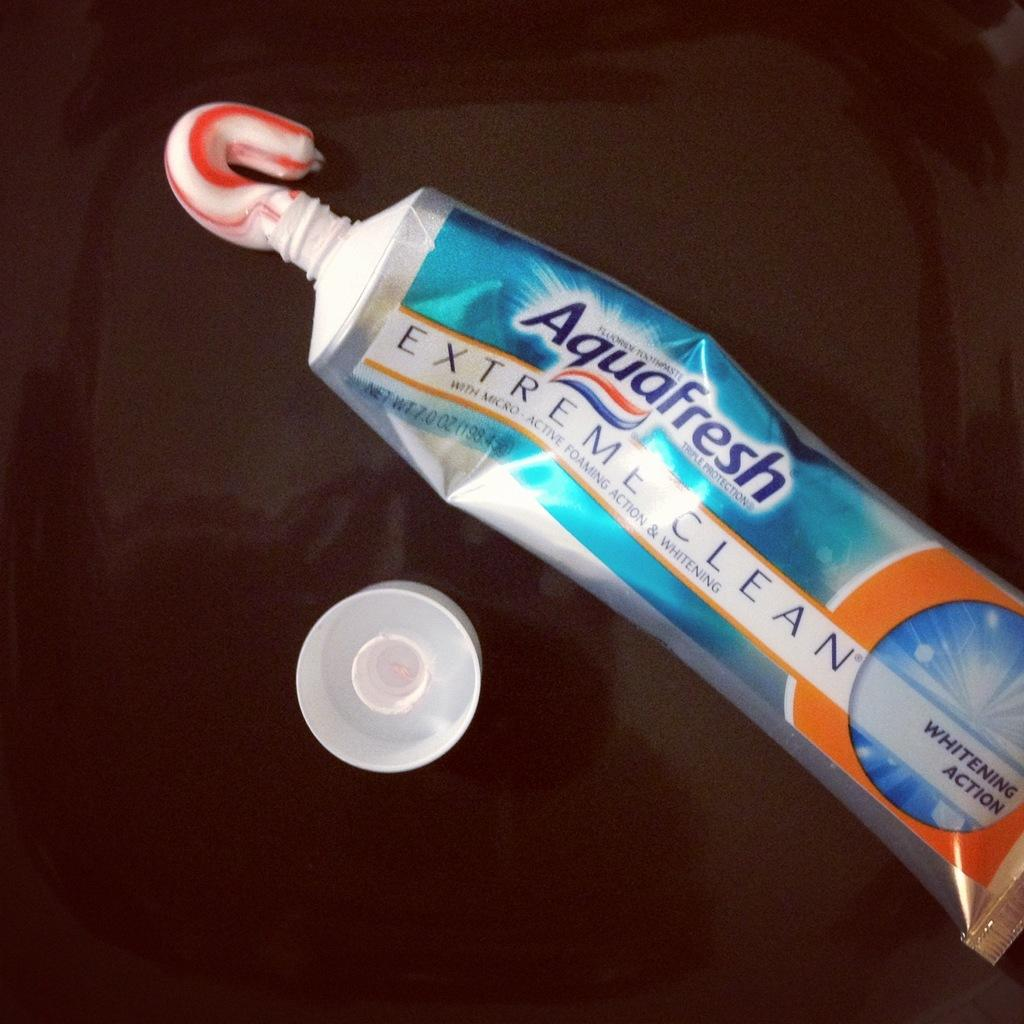<image>
Give a short and clear explanation of the subsequent image. A tube of Aquafresh extreme clean toothpaste with the cap off. 